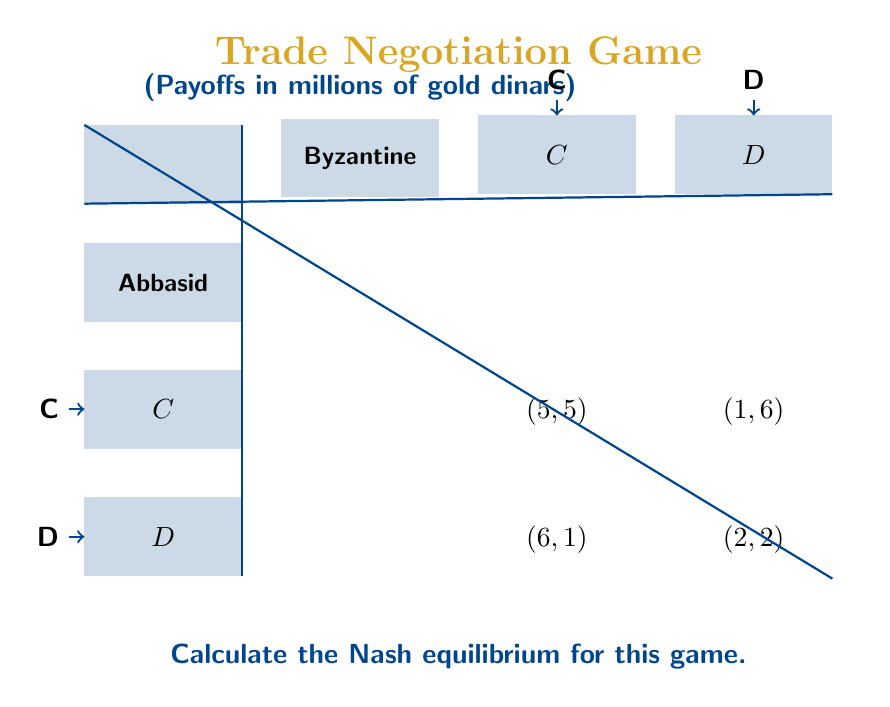Solve this math problem. To find the Nash equilibrium, we need to analyze each player's best response to the other player's strategy:

1. For the Abbasid Caliphate:
   - If Byzantine chooses C, Abbasid's best response is D (6 > 5)
   - If Byzantine chooses D, Abbasid's best response is D (2 > 1)

2. For the Byzantine Empire:
   - If Abbasid chooses C, Byzantine's best response is D (6 > 5)
   - If Abbasid chooses D, Byzantine's best response is D (2 > 1)

We can see that regardless of what the other player does, both empires have a dominant strategy to defect (D).

3. The Nash equilibrium occurs when both players are playing their best response to the other's strategy. In this case, it's when both choose to defect (D, D).

4. We can verify this by checking if any player has an incentive to unilaterally change their strategy:
   - If Abbasid switches to C while Byzantine stays at D: 1 < 2
   - If Byzantine switches to C while Abbasid stays at D: 1 < 2

Neither player can improve their payoff by changing their strategy alone, confirming that (D, D) is indeed the Nash equilibrium.

5. The payoff at this equilibrium is (2, 2), representing 2 million gold dinars for each empire.

This outcome reflects the historical challenges in maintaining stable trade relations between rival empires, often leading to suboptimal results for both parties due to mutual distrust and competition.
Answer: $$(D, D)$$ with payoffs $$(2, 2)$$ 